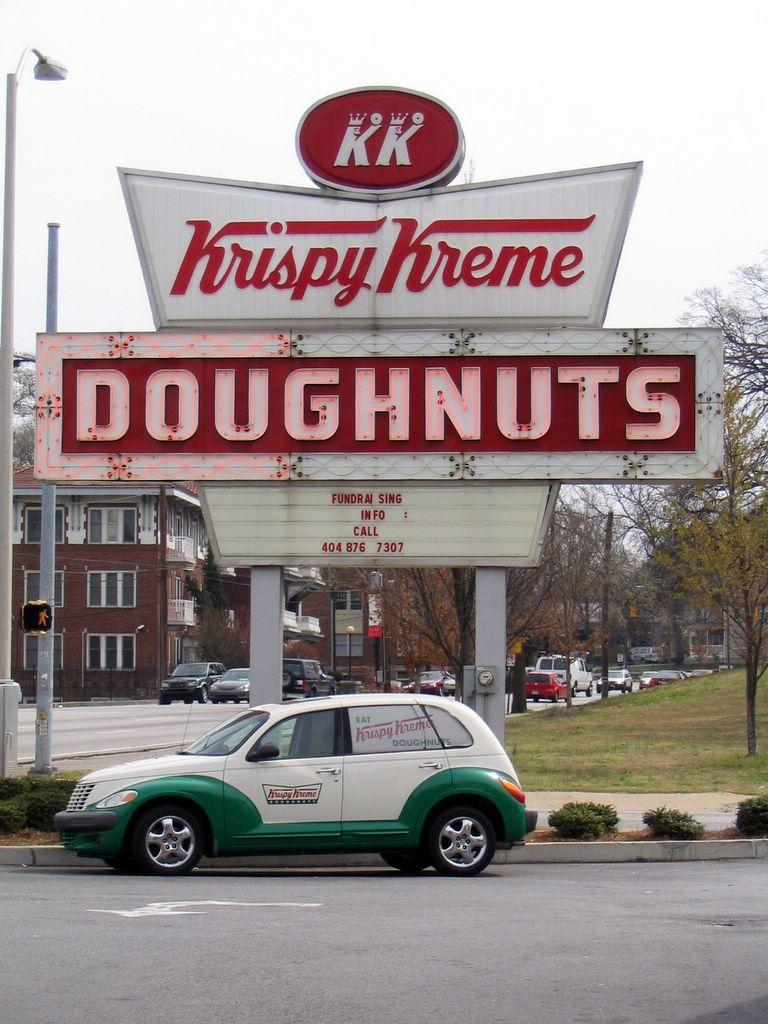What is written on the arch in the image? The text "doughnuts" is written on the arch in the image. What can be seen on the road in the image? There are many vehicles on the road in the image. What type of vegetation is visible in the image? There are trees visible in the image. What type of structures can be seen in the image? There are buildings in the image. What else is present in the image besides the arch, vehicles, trees, and buildings? There are poles in the image. What is visible in the background of the image? The sky is visible in the image. How does the image compare to a street filled with pies? The image does not depict a street filled with pies; it features an arch with the text "doughnuts" and other elements such as vehicles, trees, buildings, poles, and the sky. 